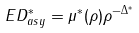Convert formula to latex. <formula><loc_0><loc_0><loc_500><loc_500>E D ^ { * } _ { a s y } = \mu ^ { * } ( \rho ) \rho ^ { - \Delta ^ { * } }</formula> 